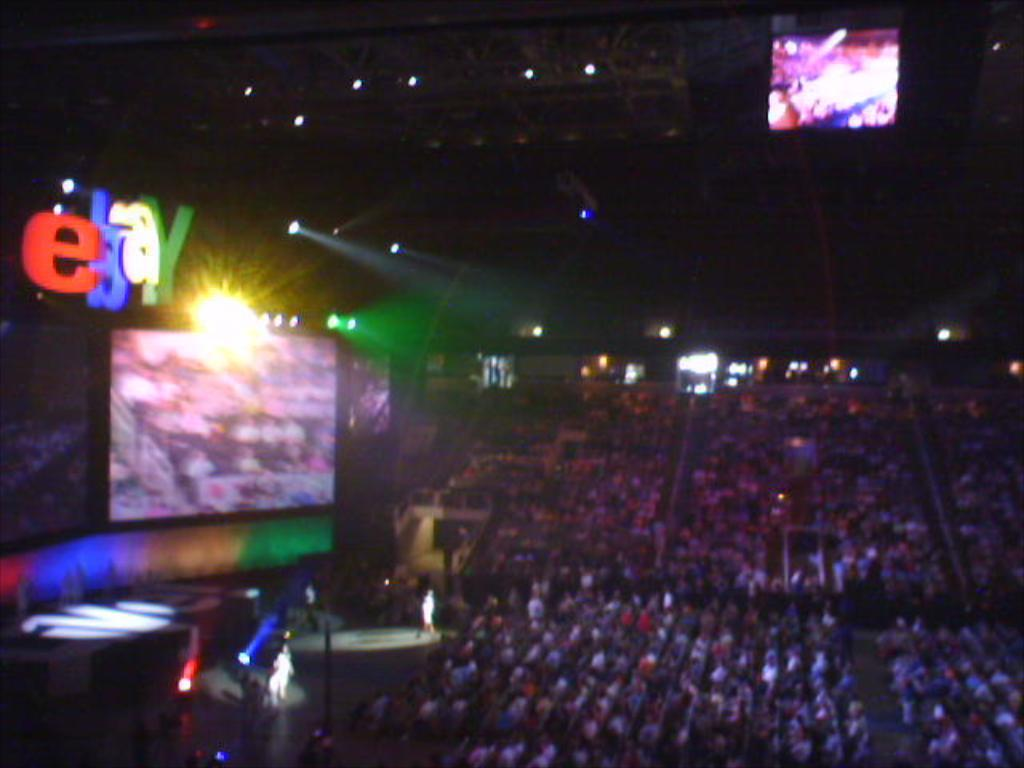Provide a one-sentence caption for the provided image. an arena filled with people with a big monitor and EBAY over it. 